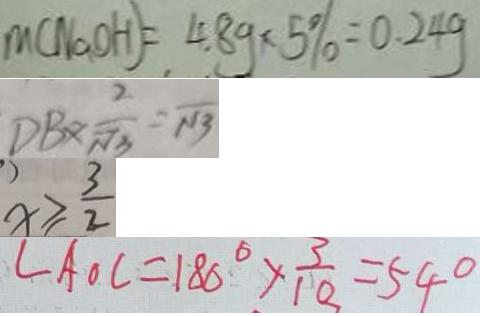<formula> <loc_0><loc_0><loc_500><loc_500>m ( N a O H ) = 4 . 8 g \times 5 \% = 0 . 2 4 g 
 D B \times \frac { 2 } { \sqrt { 3 } } = \sqrt { 1 3 } 
 x \geq \frac { 3 } { 2 } 
 \angle A O C = 1 8 0 ^ { \circ } \times \frac { 3 } { 1 0 } = 5 4 ^ { \circ }</formula> 